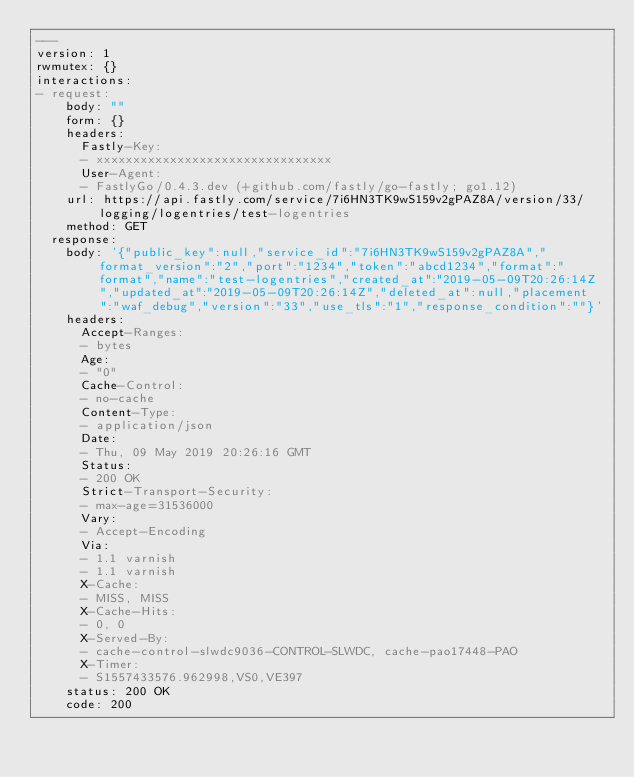Convert code to text. <code><loc_0><loc_0><loc_500><loc_500><_YAML_>---
version: 1
rwmutex: {}
interactions:
- request:
    body: ""
    form: {}
    headers:
      Fastly-Key:
      - xxxxxxxxxxxxxxxxxxxxxxxxxxxxxxxx
      User-Agent:
      - FastlyGo/0.4.3.dev (+github.com/fastly/go-fastly; go1.12)
    url: https://api.fastly.com/service/7i6HN3TK9wS159v2gPAZ8A/version/33/logging/logentries/test-logentries
    method: GET
  response:
    body: '{"public_key":null,"service_id":"7i6HN3TK9wS159v2gPAZ8A","format_version":"2","port":"1234","token":"abcd1234","format":"format","name":"test-logentries","created_at":"2019-05-09T20:26:14Z","updated_at":"2019-05-09T20:26:14Z","deleted_at":null,"placement":"waf_debug","version":"33","use_tls":"1","response_condition":""}'
    headers:
      Accept-Ranges:
      - bytes
      Age:
      - "0"
      Cache-Control:
      - no-cache
      Content-Type:
      - application/json
      Date:
      - Thu, 09 May 2019 20:26:16 GMT
      Status:
      - 200 OK
      Strict-Transport-Security:
      - max-age=31536000
      Vary:
      - Accept-Encoding
      Via:
      - 1.1 varnish
      - 1.1 varnish
      X-Cache:
      - MISS, MISS
      X-Cache-Hits:
      - 0, 0
      X-Served-By:
      - cache-control-slwdc9036-CONTROL-SLWDC, cache-pao17448-PAO
      X-Timer:
      - S1557433576.962998,VS0,VE397
    status: 200 OK
    code: 200
</code> 